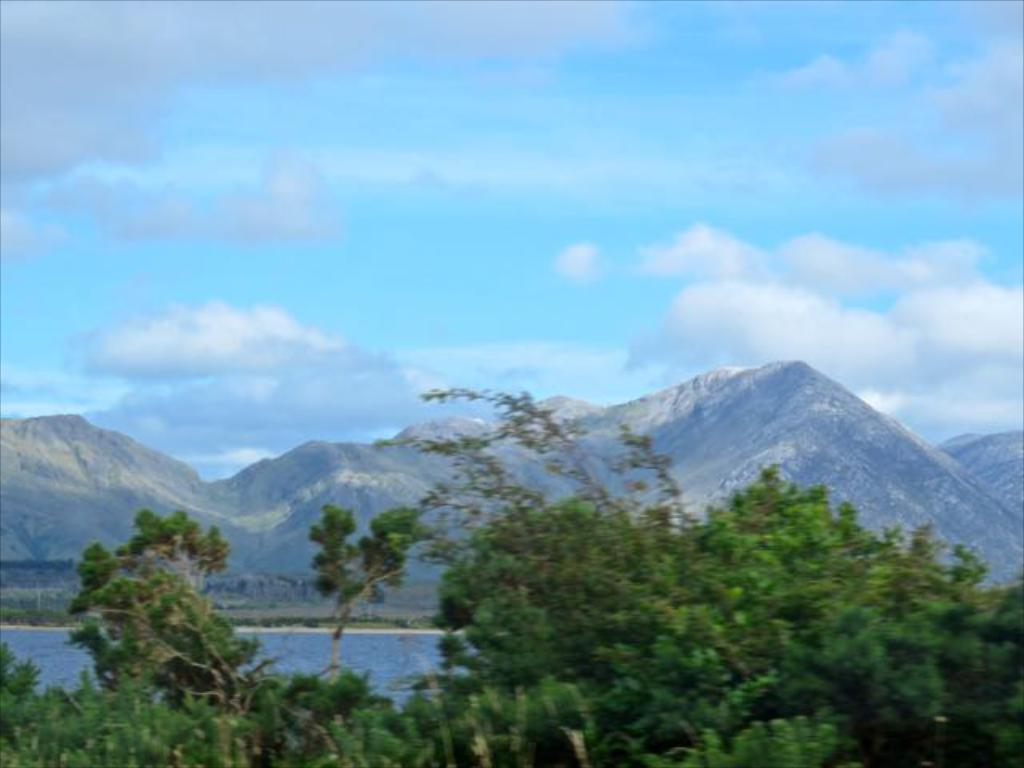What type of natural environment can be seen in the image? There are trees, water, and a stony surface visible in the image. What is the water in the image? The water in the image could be an ocean or a river. What is the stony surface in the image? The stony surface in the image could be mountains. What is visible in the sky in the image? Clouds are visible in the sky in the image. Who is the governor mentioned in the image? There is no mention of a governor or any political figures in the image. 